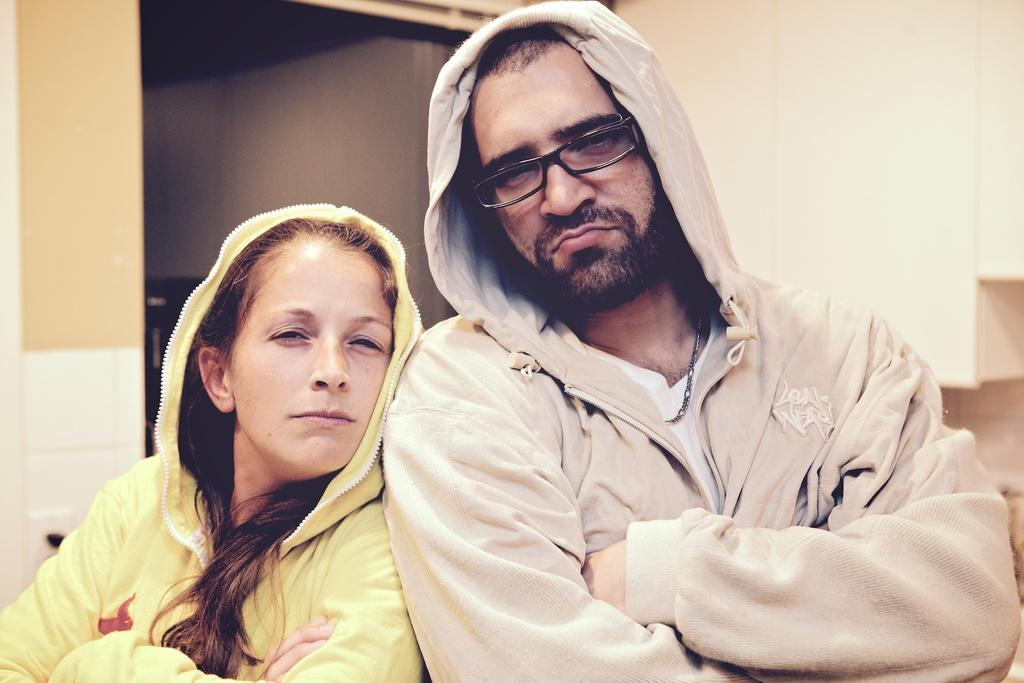How many people are wearing hoodies in the image? There are two people wearing hoodies in the image. Can you describe one of the people in the image? One man is wearing spectacles in the image. What can be seen in the background of the image? There is a wall, a table, cupboards, and a roof in the background of the image. What type of letters are the people in the image discussing? There is no indication in the image that the people are discussing letters, as the provided facts do not mention any letters or communication. --- Facts: 1. There is a person in the image. 2. The person is holding a book. 3. The book is open. 4. The person is sitting on a chair. 5. There is a table next to the person. Absurd Topics: elephant, parrot Conversation: How many people are in the image? There is one person in the image. What is the person holding in the image? The person is holding a book. Is the book open or closed? The book is open. What is the person doing in the image? The person is sitting on a chair. Is there any furniture in the image? Yes, there is a table next to the person. Reasoning: Let's think step by step in order to produce the conversation. We start by identifying the main subject of the image, which is the person. Next, we describe specific details about the person, such as the book they are holding, and whether it is open or closed. Then, we observe the actions of the person, noting that they are sitting on a chair. Finally, we describe the presence of any furniture in the image, which in this case is a table next to the person. Absurd Question/Answer: How many elephants can be seen in the image? There are no elephants present in the image. --- Facts: 1. There is a dog in the image. 2. The dog is sitting on the grass. 3. The dog is wearing a collar. 4. There is a tree in the background of the image. 5. The sky is visible in the image. Absurd Topics: piano Conversation: What type of animal is in the image? There is a dog in the image. What is the dog doing in the image? The dog is sitting on the grass. Is the dog wearing any accessories in the image? Yes, the dog is wearing a collar. What can be seen in the background of the image? There is a tree in the background of the image. What part of the natural environment is visible in the image? The sky is visible in the image. Reasoning: Let's think step by step in order to produce the conversation. We start by identifying the main subject of the image, which is the 